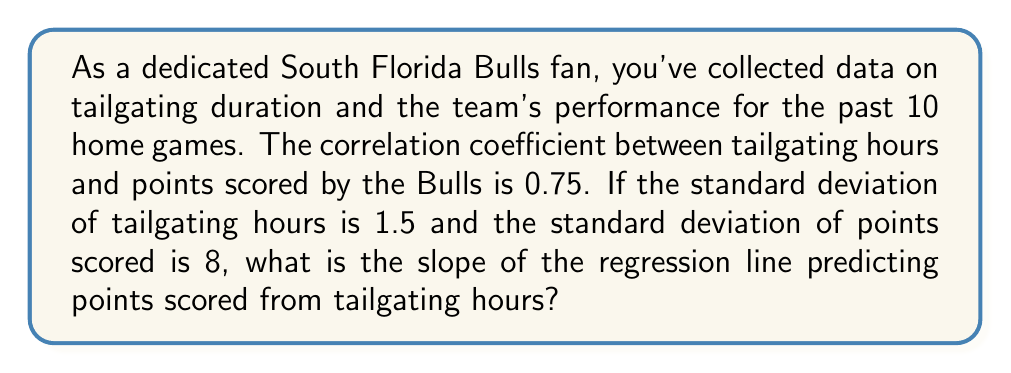What is the answer to this math problem? Let's approach this step-by-step:

1) The slope of a regression line is given by the formula:

   $$b = r \cdot \frac{s_y}{s_x}$$

   Where:
   $b$ = slope of the regression line
   $r$ = correlation coefficient
   $s_y$ = standard deviation of the dependent variable (points scored)
   $s_x$ = standard deviation of the independent variable (tailgating hours)

2) We are given:
   $r = 0.75$
   $s_x = 1.5$ (standard deviation of tailgating hours)
   $s_y = 8$ (standard deviation of points scored)

3) Let's substitute these values into the formula:

   $$b = 0.75 \cdot \frac{8}{1.5}$$

4) Simplify:
   $$b = 0.75 \cdot \frac{16}{3}$$

5) Calculate:
   $$b = 4$$

Therefore, the slope of the regression line is 4.
Answer: 4 